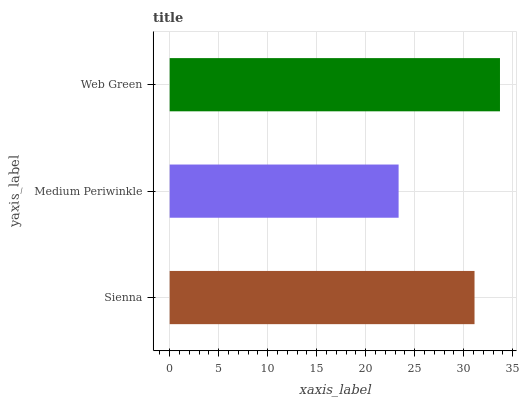Is Medium Periwinkle the minimum?
Answer yes or no. Yes. Is Web Green the maximum?
Answer yes or no. Yes. Is Web Green the minimum?
Answer yes or no. No. Is Medium Periwinkle the maximum?
Answer yes or no. No. Is Web Green greater than Medium Periwinkle?
Answer yes or no. Yes. Is Medium Periwinkle less than Web Green?
Answer yes or no. Yes. Is Medium Periwinkle greater than Web Green?
Answer yes or no. No. Is Web Green less than Medium Periwinkle?
Answer yes or no. No. Is Sienna the high median?
Answer yes or no. Yes. Is Sienna the low median?
Answer yes or no. Yes. Is Medium Periwinkle the high median?
Answer yes or no. No. Is Web Green the low median?
Answer yes or no. No. 